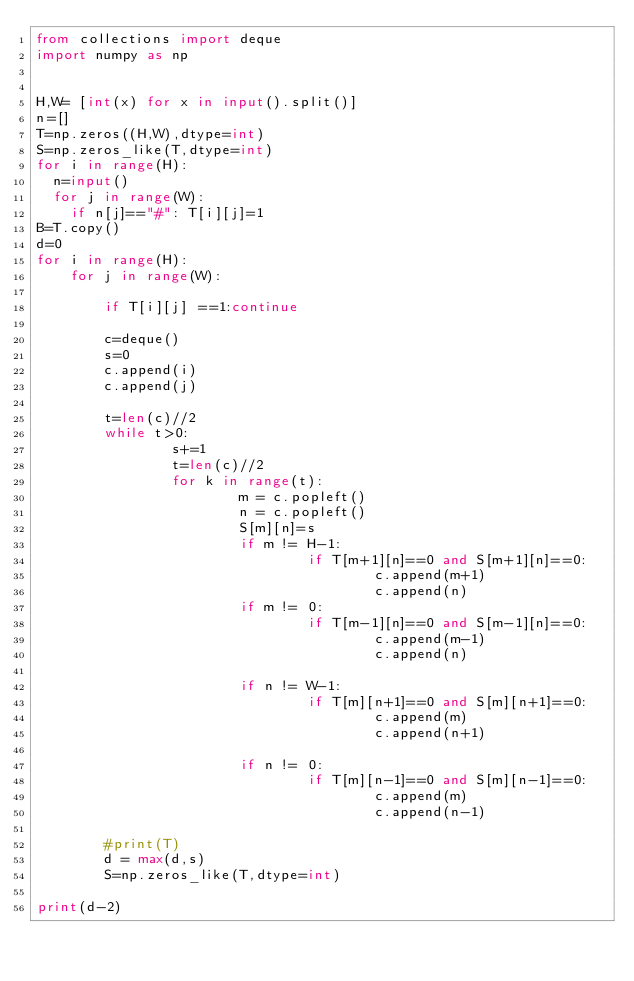<code> <loc_0><loc_0><loc_500><loc_500><_Python_>from collections import deque
import numpy as np
 
 
H,W= [int(x) for x in input().split()]
n=[]
T=np.zeros((H,W),dtype=int)
S=np.zeros_like(T,dtype=int) 
for i in range(H):
  n=input()
  for j in range(W):
    if n[j]=="#": T[i][j]=1
B=T.copy()    
d=0
for i in range(H):
    for j in range(W):
         
        if T[i][j] ==1:continue
 
        c=deque()    
        s=0
        c.append(i)
        c.append(j)
        
        t=len(c)//2
        while t>0:
                s+=1
                t=len(c)//2
                for k in range(t):
                        m = c.popleft()
                        n = c.popleft()
                        S[m][n]=s
                        if m != H-1:
                                if T[m+1][n]==0 and S[m+1][n]==0:
                                        c.append(m+1)
                                        c.append(n)
                        if m != 0:
                                if T[m-1][n]==0 and S[m-1][n]==0:
                                        c.append(m-1)
                                        c.append(n)
 
                        if n != W-1:
                                if T[m][n+1]==0 and S[m][n+1]==0:
                                        c.append(m)
                                        c.append(n+1)
                                        
                        if n != 0:
                                if T[m][n-1]==0 and S[m][n-1]==0:
                                        c.append(m)
                                        c.append(n-1)
 
        #print(T)
        d = max(d,s)
        S=np.zeros_like(T,dtype=int)
        
print(d-2)</code> 